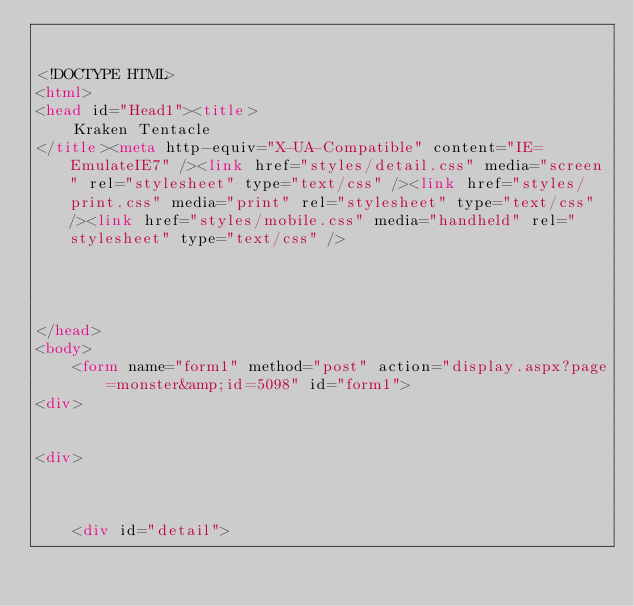Convert code to text. <code><loc_0><loc_0><loc_500><loc_500><_HTML_>

<!DOCTYPE HTML>
<html>
<head id="Head1"><title>
	Kraken Tentacle
</title><meta http-equiv="X-UA-Compatible" content="IE=EmulateIE7" /><link href="styles/detail.css" media="screen" rel="stylesheet" type="text/css" /><link href="styles/print.css" media="print" rel="stylesheet" type="text/css" /><link href="styles/mobile.css" media="handheld" rel="stylesheet" type="text/css" />
    
    
    

</head>
<body>
    <form name="form1" method="post" action="display.aspx?page=monster&amp;id=5098" id="form1">
<div>


<div>

	
	
    <div id="detail">
		</code> 